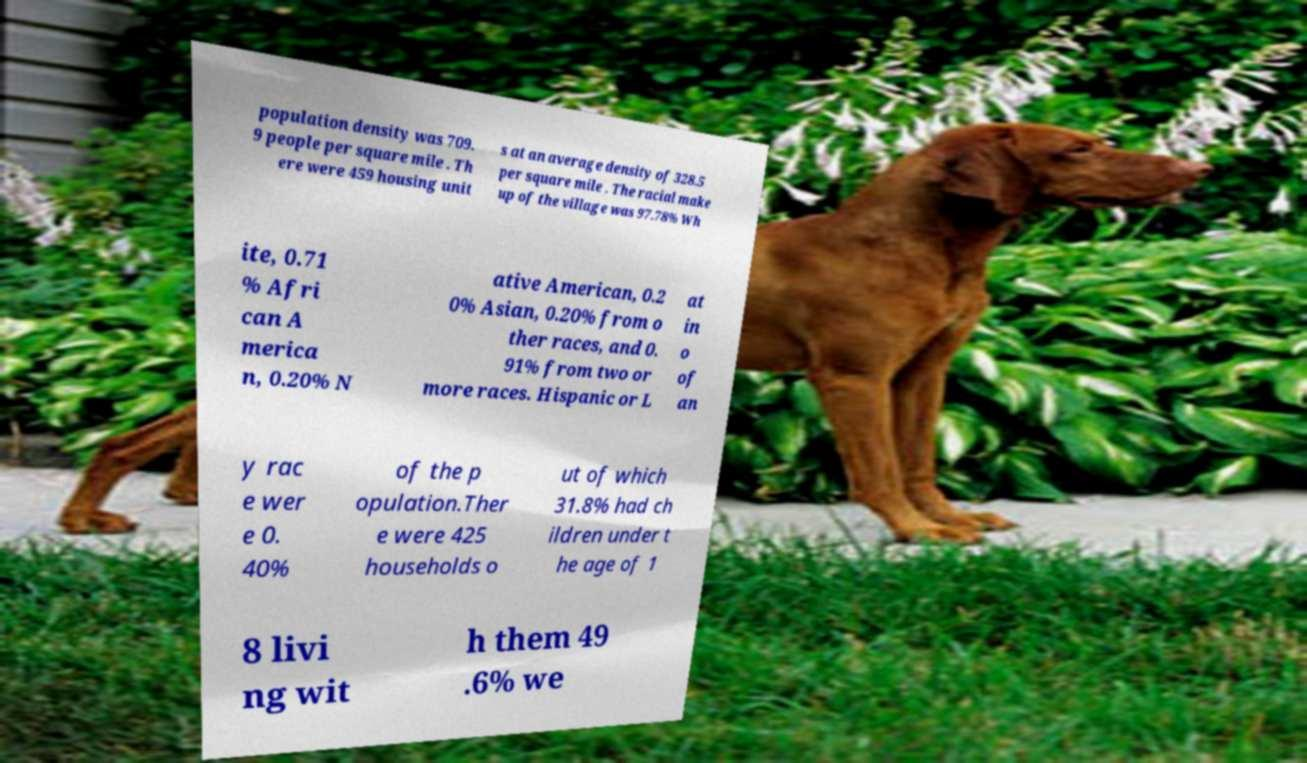Could you assist in decoding the text presented in this image and type it out clearly? population density was 709. 9 people per square mile . Th ere were 459 housing unit s at an average density of 328.5 per square mile . The racial make up of the village was 97.78% Wh ite, 0.71 % Afri can A merica n, 0.20% N ative American, 0.2 0% Asian, 0.20% from o ther races, and 0. 91% from two or more races. Hispanic or L at in o of an y rac e wer e 0. 40% of the p opulation.Ther e were 425 households o ut of which 31.8% had ch ildren under t he age of 1 8 livi ng wit h them 49 .6% we 